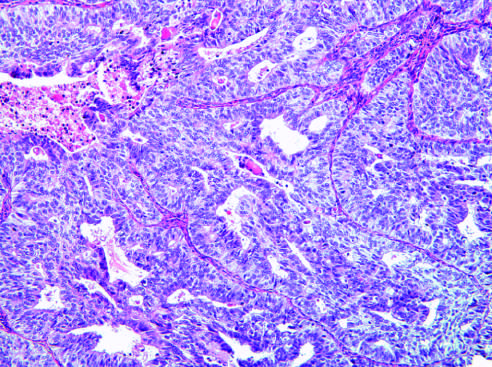does endometrioid type, grade 3, have a predominantly solid growth pattern?
Answer the question using a single word or phrase. Yes 